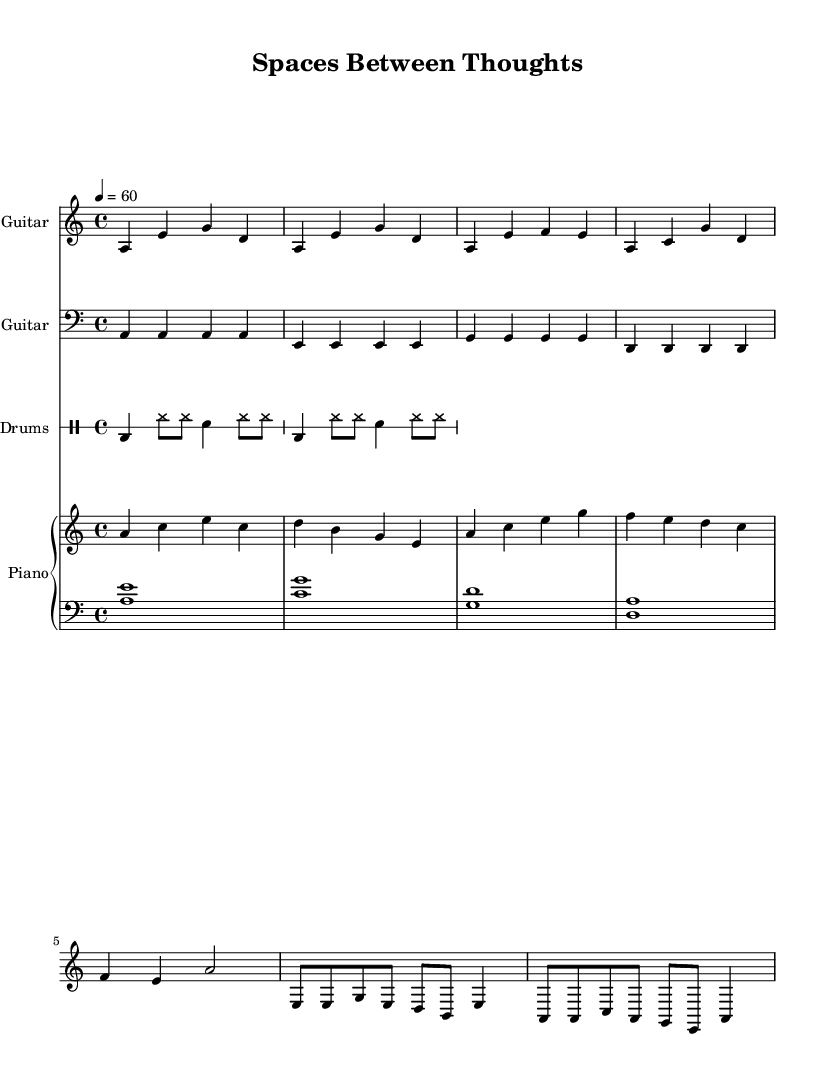What is the key signature of this music? The key signature is A minor, which has no sharps or flats.
Answer: A minor What is the time signature of this piece? The time signature is 4/4, indicating four beats per measure.
Answer: 4/4 What is the tempo marking for this piece? The tempo marking indicates a speed of 60 beats per minute, which is relatively slow.
Answer: 60 How many measures are in the guitar riff section? The guitar riff section contains a total of 8 measures, based on the provided music segments.
Answer: 8 What is the primary instrumentation used in this piece? The primary instrumentation includes electric guitar, bass guitar, drums, and piano, creating a full electric blues band sound.
Answer: Electric guitar, bass guitar, drums, piano What emotion does the use of A minor likely convey in this electric blues track? The use of A minor typically evokes a feeling of sadness or contemplation, aligning with the introspective nature suggested by the piece’s title.
Answer: Contemplation How does the chord progression in the chorus influence the perception of space in the music? The progression moves through A minor, C major, G major, and D major, creating a sense of movement and exploration that mirrors the theme of spatial contemplation.
Answer: Sense of movement 